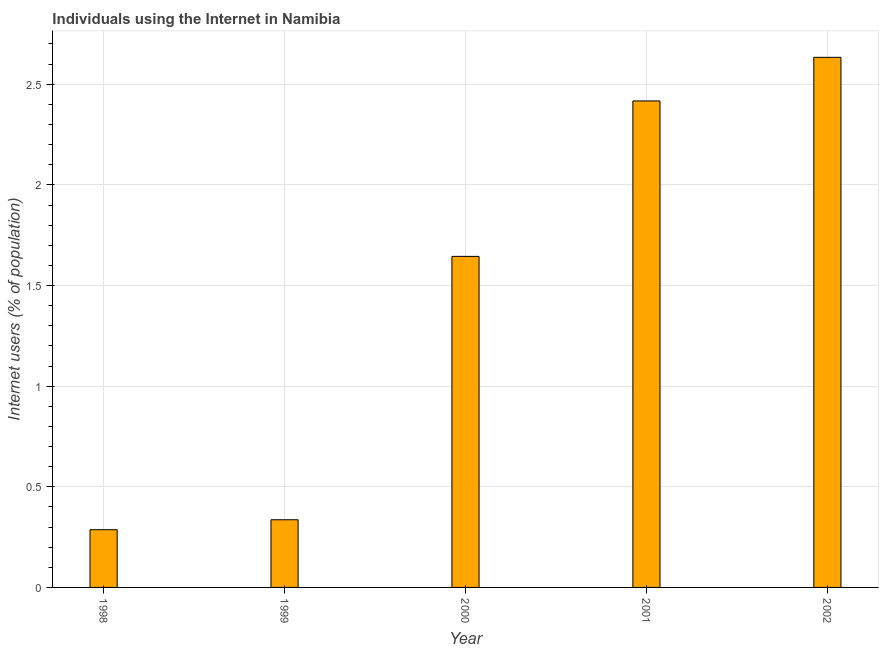Does the graph contain any zero values?
Give a very brief answer. No. What is the title of the graph?
Make the answer very short. Individuals using the Internet in Namibia. What is the label or title of the Y-axis?
Make the answer very short. Internet users (% of population). What is the number of internet users in 2000?
Ensure brevity in your answer.  1.64. Across all years, what is the maximum number of internet users?
Your answer should be very brief. 2.63. Across all years, what is the minimum number of internet users?
Your response must be concise. 0.29. In which year was the number of internet users minimum?
Provide a succinct answer. 1998. What is the sum of the number of internet users?
Make the answer very short. 7.32. What is the difference between the number of internet users in 1999 and 2002?
Your answer should be very brief. -2.3. What is the average number of internet users per year?
Provide a short and direct response. 1.46. What is the median number of internet users?
Keep it short and to the point. 1.64. Do a majority of the years between 1998 and 2001 (inclusive) have number of internet users greater than 0.3 %?
Keep it short and to the point. Yes. What is the ratio of the number of internet users in 1998 to that in 1999?
Provide a succinct answer. 0.85. Is the number of internet users in 2001 less than that in 2002?
Provide a succinct answer. Yes. Is the difference between the number of internet users in 1999 and 2000 greater than the difference between any two years?
Give a very brief answer. No. What is the difference between the highest and the second highest number of internet users?
Your response must be concise. 0.22. What is the difference between the highest and the lowest number of internet users?
Offer a very short reply. 2.35. How many years are there in the graph?
Offer a terse response. 5. Are the values on the major ticks of Y-axis written in scientific E-notation?
Make the answer very short. No. What is the Internet users (% of population) of 1998?
Provide a succinct answer. 0.29. What is the Internet users (% of population) of 1999?
Ensure brevity in your answer.  0.34. What is the Internet users (% of population) of 2000?
Keep it short and to the point. 1.64. What is the Internet users (% of population) of 2001?
Your answer should be compact. 2.42. What is the Internet users (% of population) in 2002?
Keep it short and to the point. 2.63. What is the difference between the Internet users (% of population) in 1998 and 1999?
Make the answer very short. -0.05. What is the difference between the Internet users (% of population) in 1998 and 2000?
Provide a succinct answer. -1.36. What is the difference between the Internet users (% of population) in 1998 and 2001?
Your answer should be very brief. -2.13. What is the difference between the Internet users (% of population) in 1998 and 2002?
Your response must be concise. -2.35. What is the difference between the Internet users (% of population) in 1999 and 2000?
Provide a short and direct response. -1.31. What is the difference between the Internet users (% of population) in 1999 and 2001?
Ensure brevity in your answer.  -2.08. What is the difference between the Internet users (% of population) in 1999 and 2002?
Ensure brevity in your answer.  -2.3. What is the difference between the Internet users (% of population) in 2000 and 2001?
Give a very brief answer. -0.77. What is the difference between the Internet users (% of population) in 2000 and 2002?
Make the answer very short. -0.99. What is the difference between the Internet users (% of population) in 2001 and 2002?
Your response must be concise. -0.22. What is the ratio of the Internet users (% of population) in 1998 to that in 1999?
Your answer should be very brief. 0.85. What is the ratio of the Internet users (% of population) in 1998 to that in 2000?
Your answer should be very brief. 0.17. What is the ratio of the Internet users (% of population) in 1998 to that in 2001?
Your answer should be compact. 0.12. What is the ratio of the Internet users (% of population) in 1998 to that in 2002?
Make the answer very short. 0.11. What is the ratio of the Internet users (% of population) in 1999 to that in 2000?
Keep it short and to the point. 0.2. What is the ratio of the Internet users (% of population) in 1999 to that in 2001?
Offer a terse response. 0.14. What is the ratio of the Internet users (% of population) in 1999 to that in 2002?
Give a very brief answer. 0.13. What is the ratio of the Internet users (% of population) in 2000 to that in 2001?
Offer a very short reply. 0.68. What is the ratio of the Internet users (% of population) in 2000 to that in 2002?
Give a very brief answer. 0.62. What is the ratio of the Internet users (% of population) in 2001 to that in 2002?
Give a very brief answer. 0.92. 